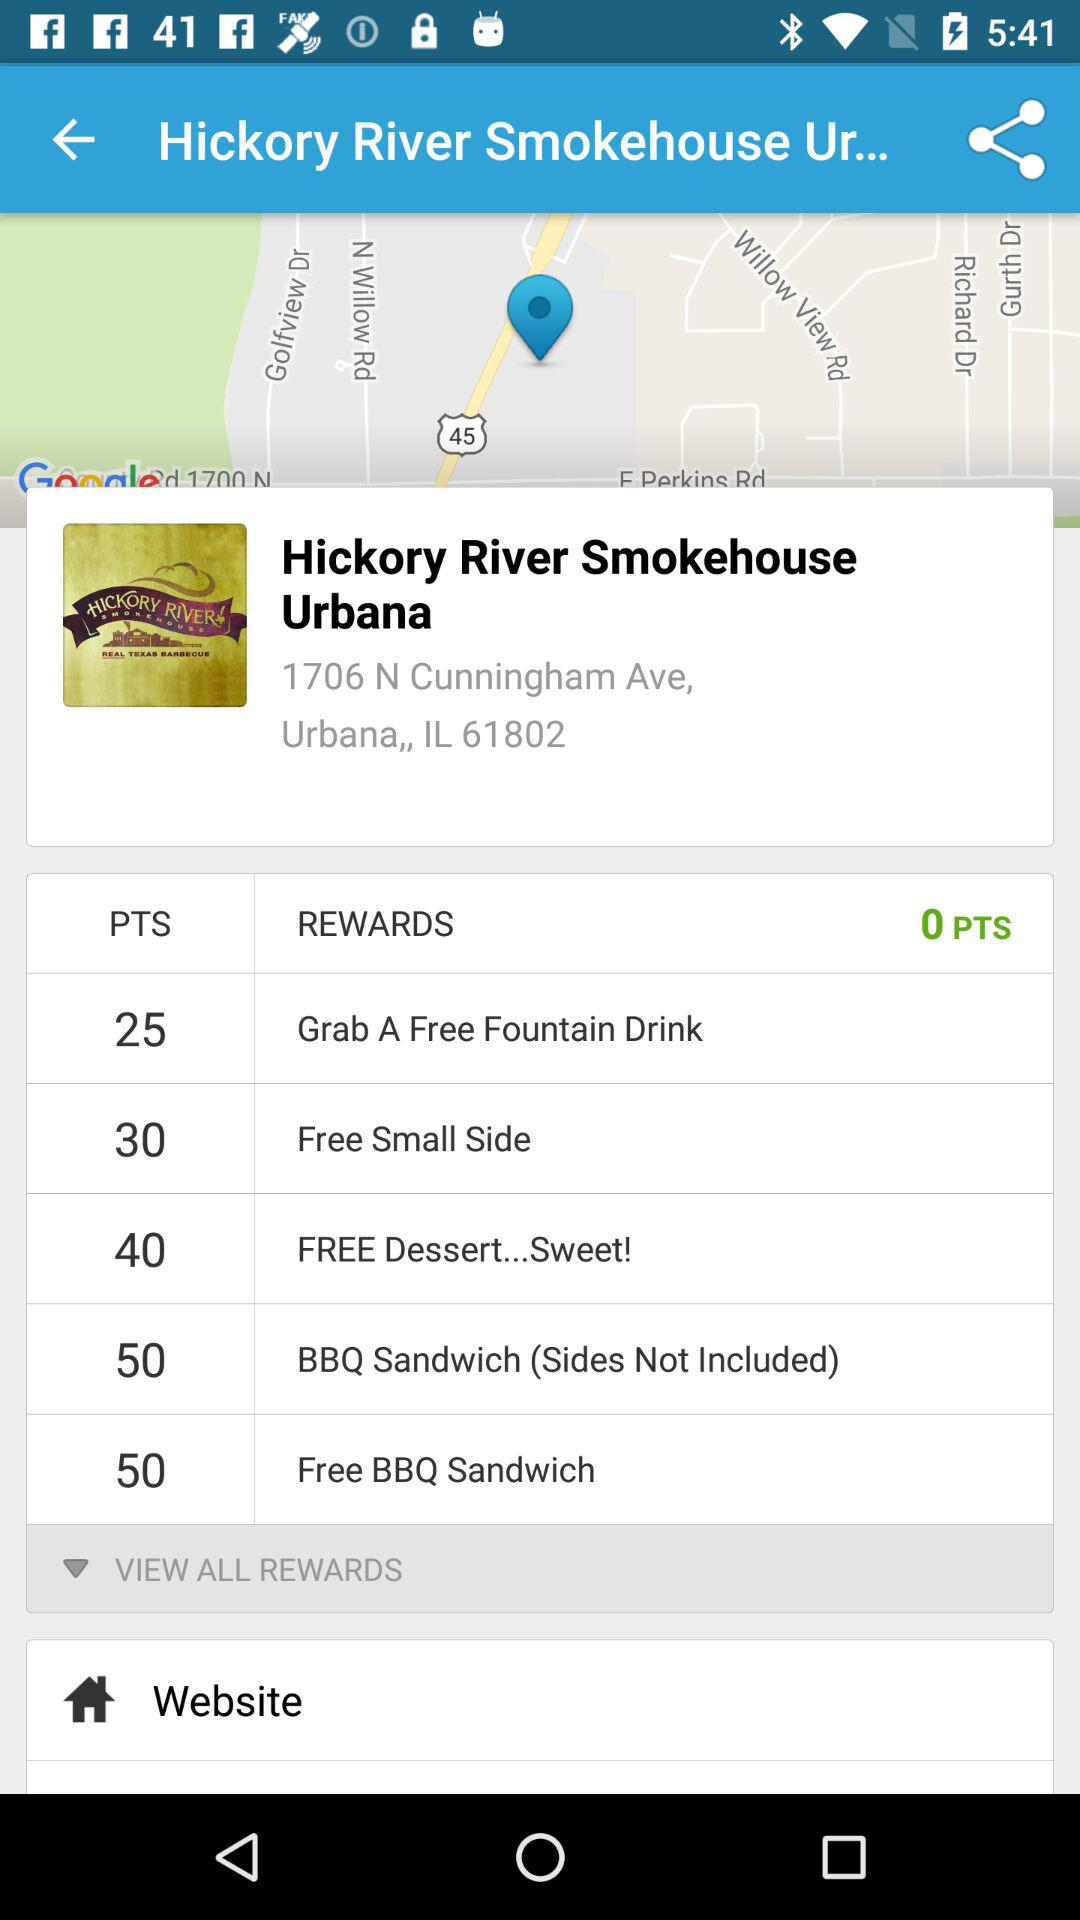How many points do I need to redeem for a free fountain drink?
Answer the question using a single word or phrase. 25 